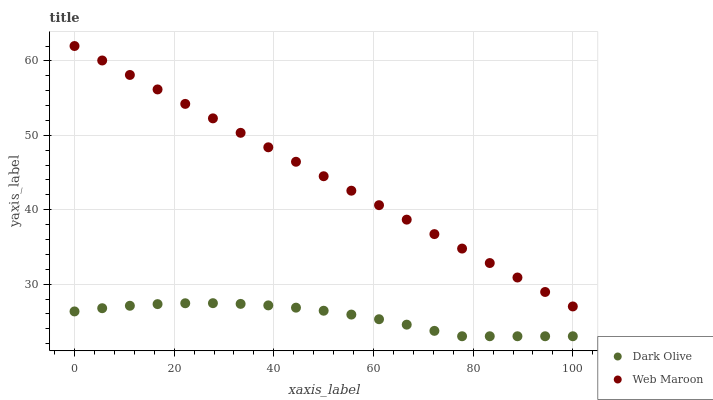Does Dark Olive have the minimum area under the curve?
Answer yes or no. Yes. Does Web Maroon have the maximum area under the curve?
Answer yes or no. Yes. Does Web Maroon have the minimum area under the curve?
Answer yes or no. No. Is Web Maroon the smoothest?
Answer yes or no. Yes. Is Dark Olive the roughest?
Answer yes or no. Yes. Is Web Maroon the roughest?
Answer yes or no. No. Does Dark Olive have the lowest value?
Answer yes or no. Yes. Does Web Maroon have the lowest value?
Answer yes or no. No. Does Web Maroon have the highest value?
Answer yes or no. Yes. Is Dark Olive less than Web Maroon?
Answer yes or no. Yes. Is Web Maroon greater than Dark Olive?
Answer yes or no. Yes. Does Dark Olive intersect Web Maroon?
Answer yes or no. No. 